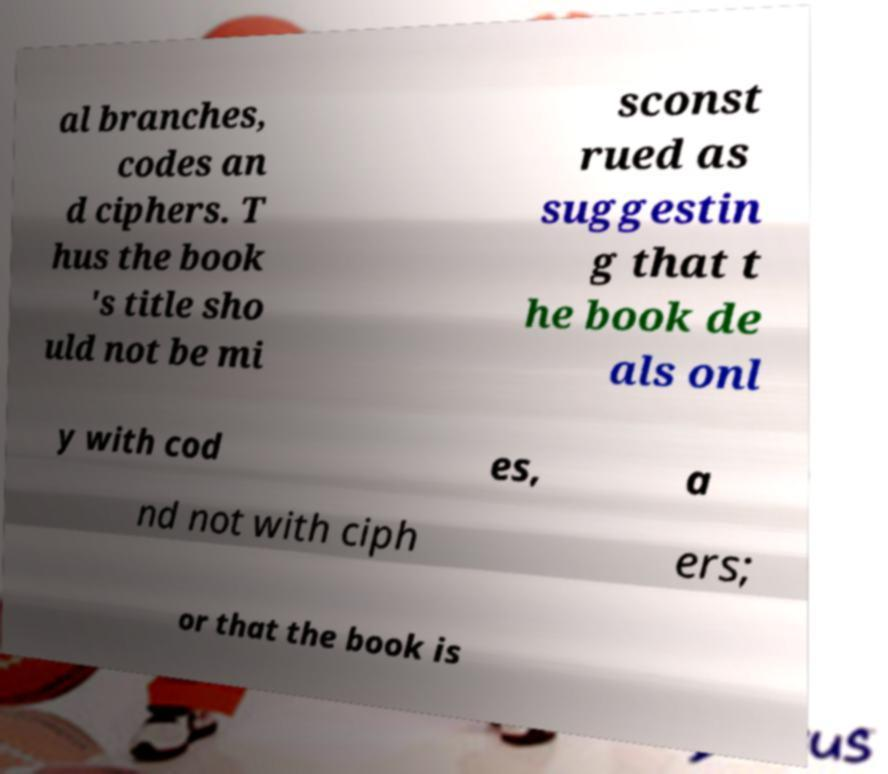Could you extract and type out the text from this image? al branches, codes an d ciphers. T hus the book 's title sho uld not be mi sconst rued as suggestin g that t he book de als onl y with cod es, a nd not with ciph ers; or that the book is 